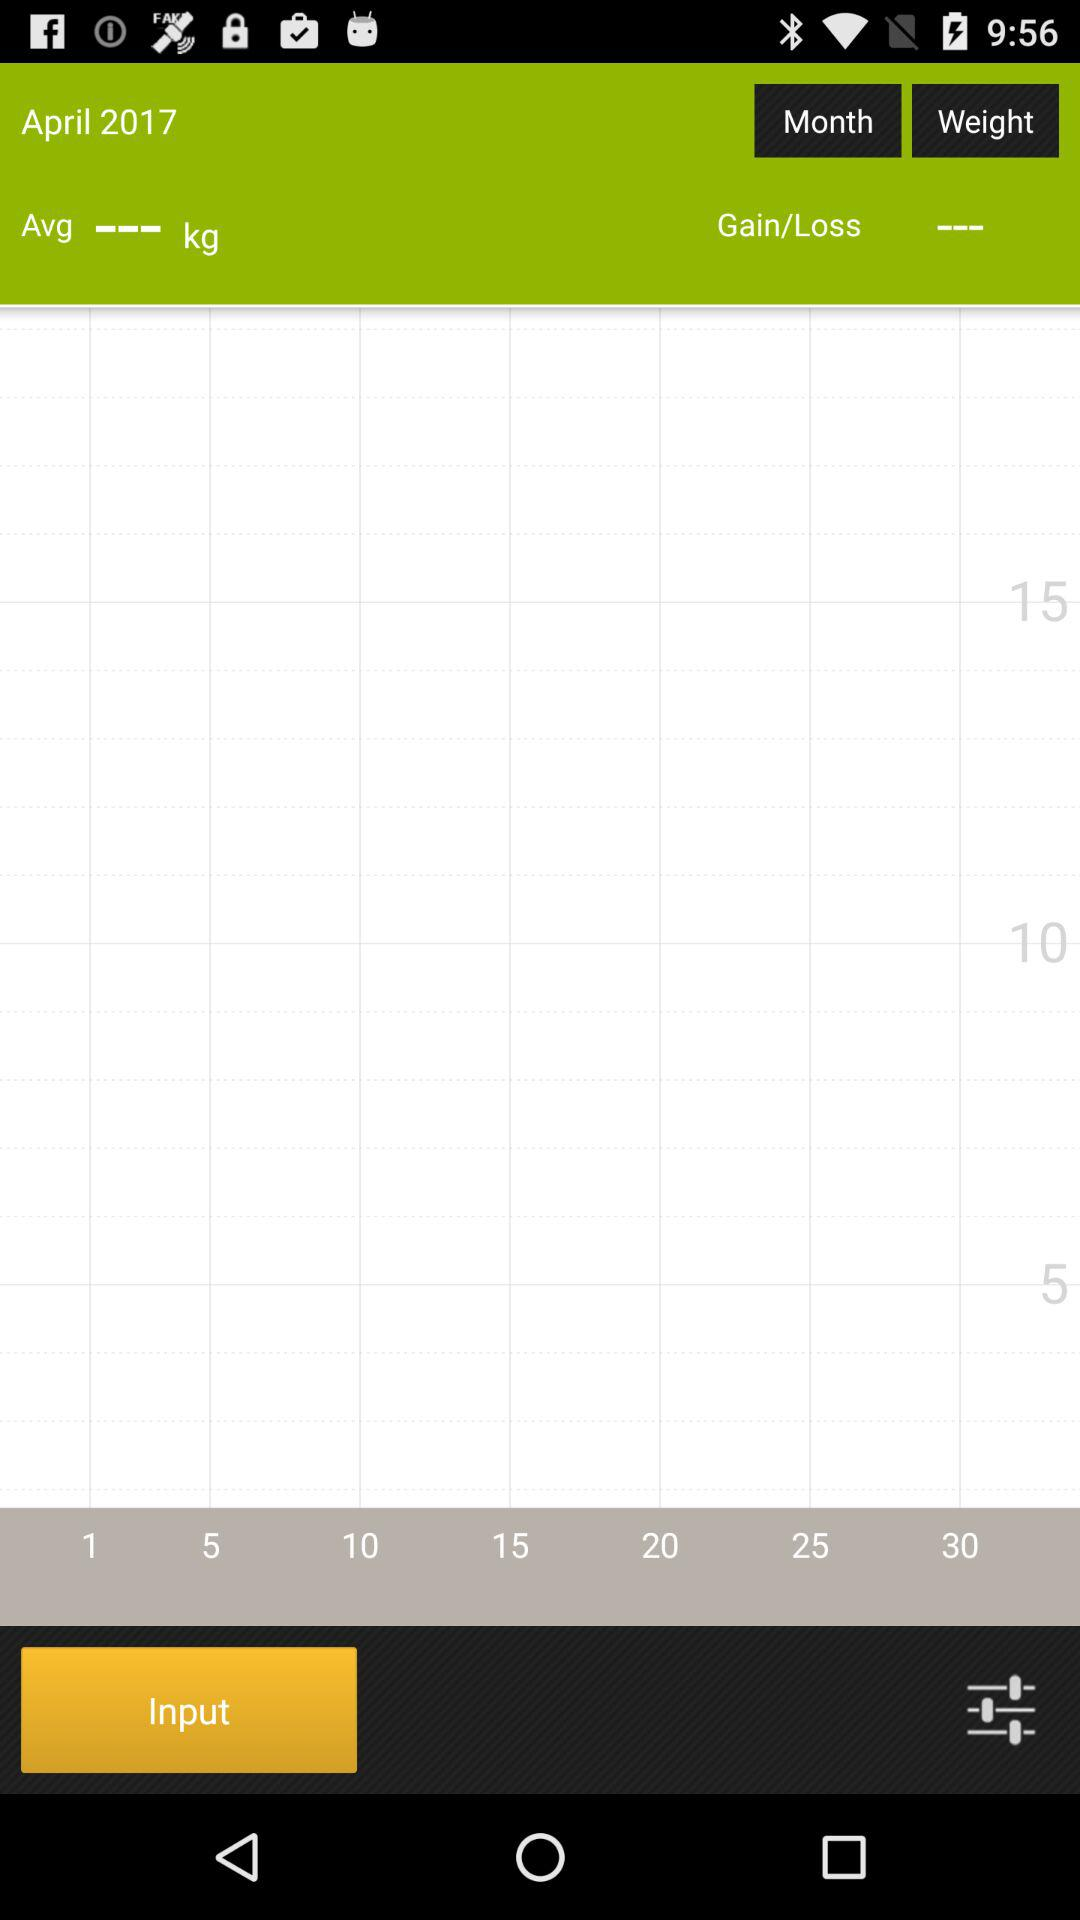How many kilograms are there between the 5kg and 20kg labels on the grid?
Answer the question using a single word or phrase. 15 